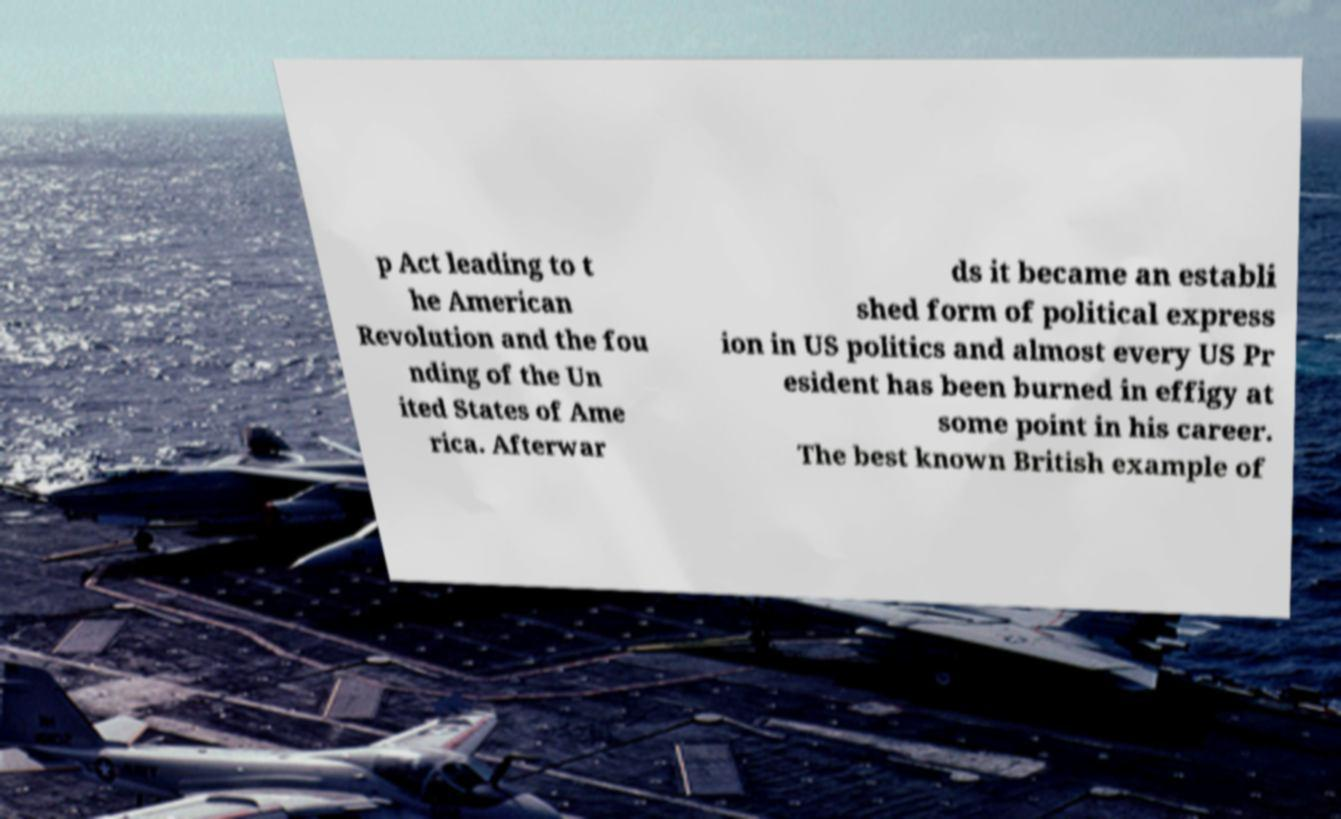For documentation purposes, I need the text within this image transcribed. Could you provide that? p Act leading to t he American Revolution and the fou nding of the Un ited States of Ame rica. Afterwar ds it became an establi shed form of political express ion in US politics and almost every US Pr esident has been burned in effigy at some point in his career. The best known British example of 